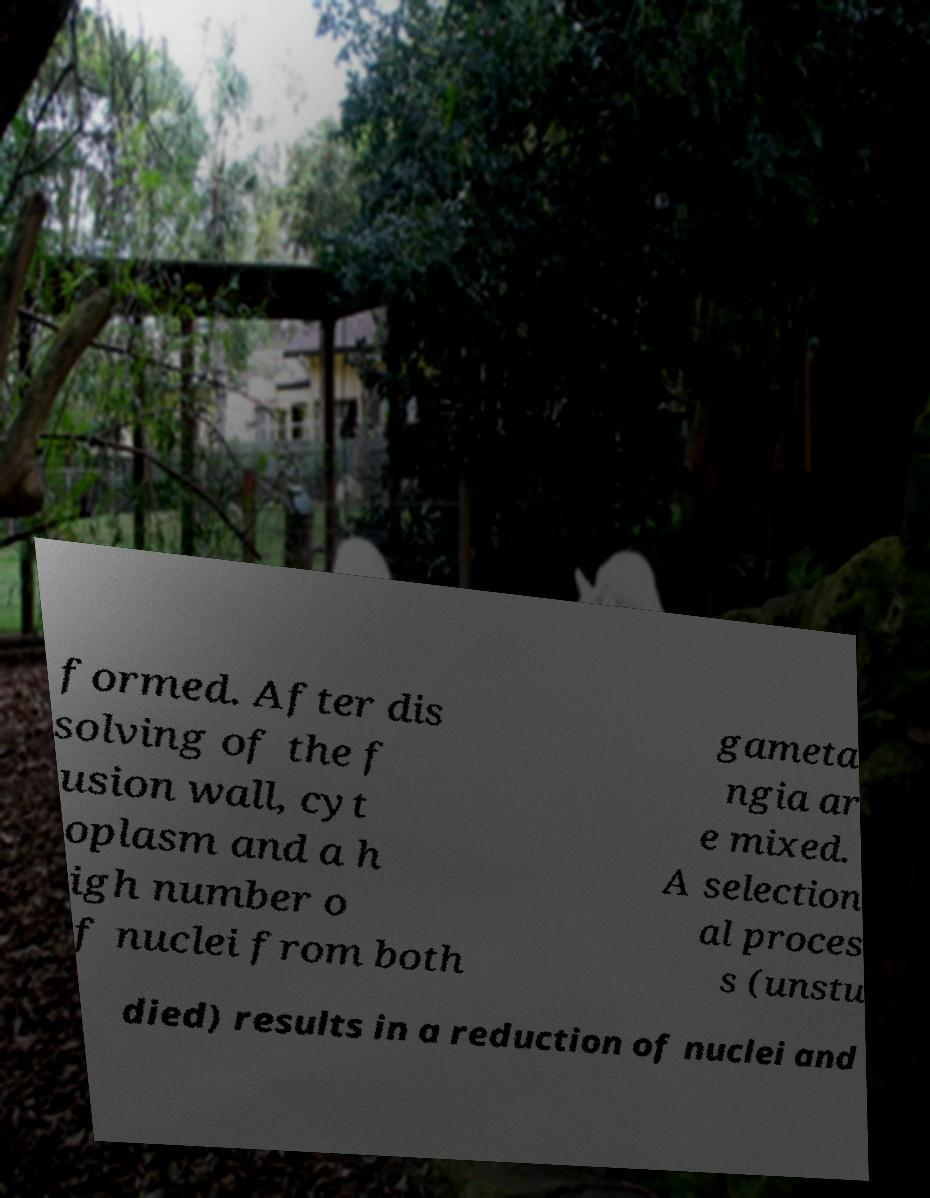Please read and relay the text visible in this image. What does it say? formed. After dis solving of the f usion wall, cyt oplasm and a h igh number o f nuclei from both gameta ngia ar e mixed. A selection al proces s (unstu died) results in a reduction of nuclei and 